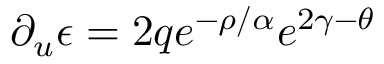Convert formula to latex. <formula><loc_0><loc_0><loc_500><loc_500>\partial _ { u } \epsilon = 2 q e ^ { - \rho / \alpha } e ^ { 2 \gamma - \theta }</formula> 